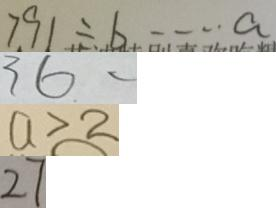<formula> <loc_0><loc_0><loc_500><loc_500>7 9 1 \div b \cdots a 
 3 6 . - 
 a > 2 
 2 7</formula> 